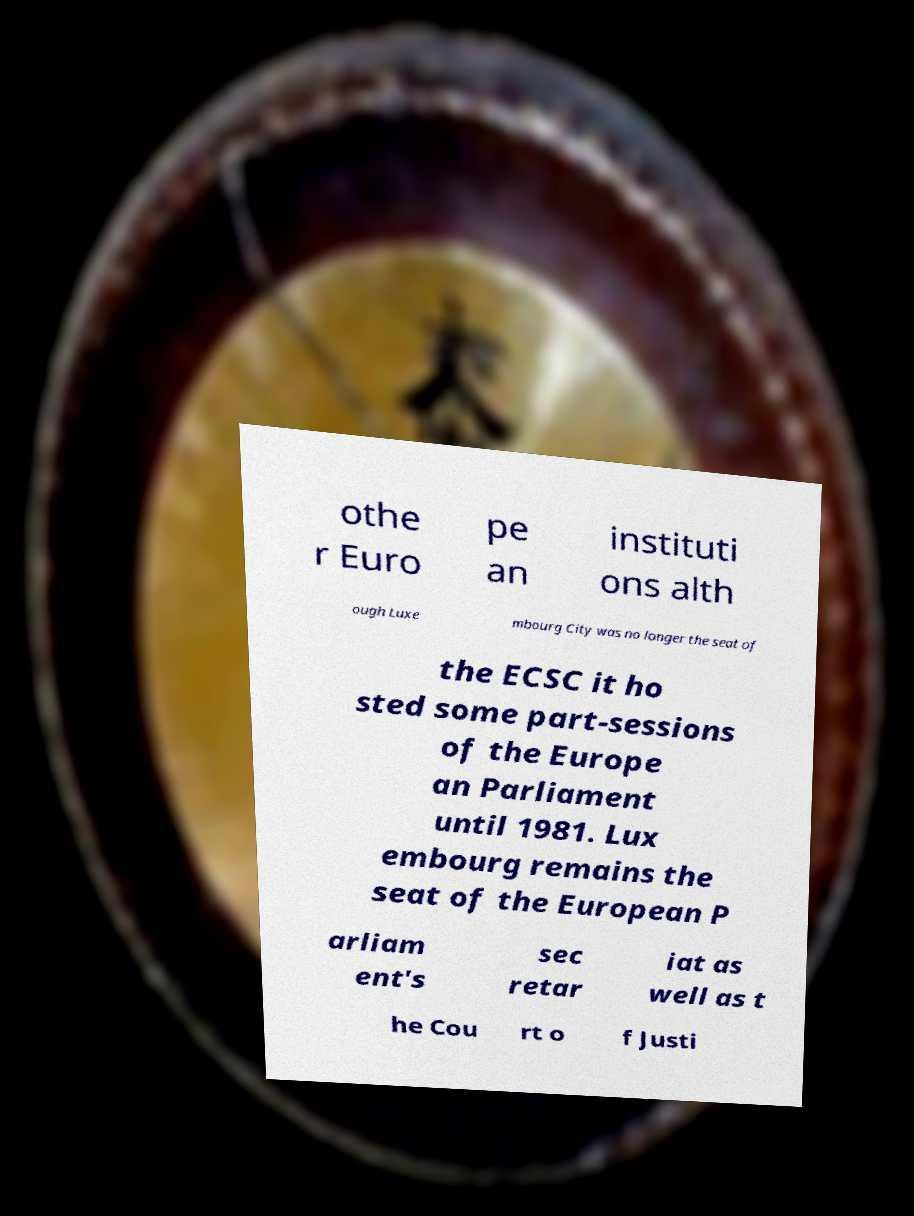Can you accurately transcribe the text from the provided image for me? othe r Euro pe an instituti ons alth ough Luxe mbourg City was no longer the seat of the ECSC it ho sted some part-sessions of the Europe an Parliament until 1981. Lux embourg remains the seat of the European P arliam ent's sec retar iat as well as t he Cou rt o f Justi 